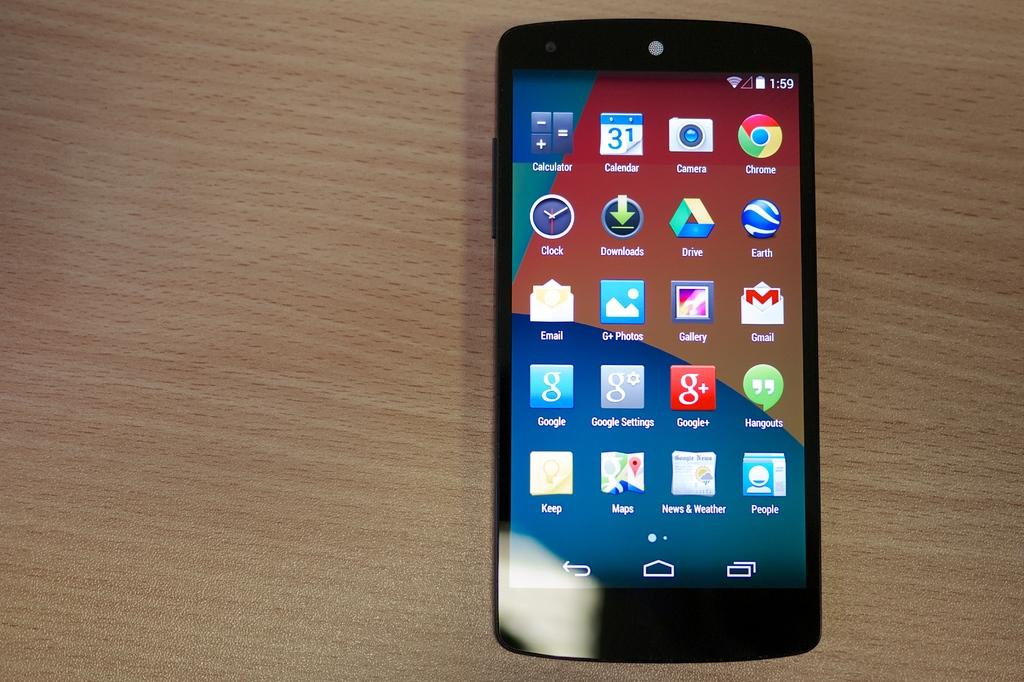<image>
Provide a brief description of the given image. A smart phone home screen shows several apps including Chrome, and other Google Apps. 